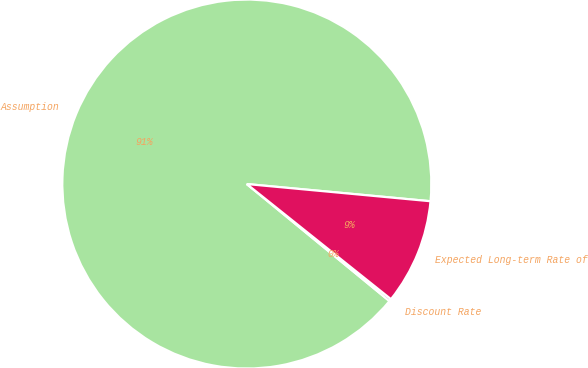<chart> <loc_0><loc_0><loc_500><loc_500><pie_chart><fcel>Assumption<fcel>Discount Rate<fcel>Expected Long-term Rate of<nl><fcel>90.54%<fcel>0.21%<fcel>9.24%<nl></chart> 